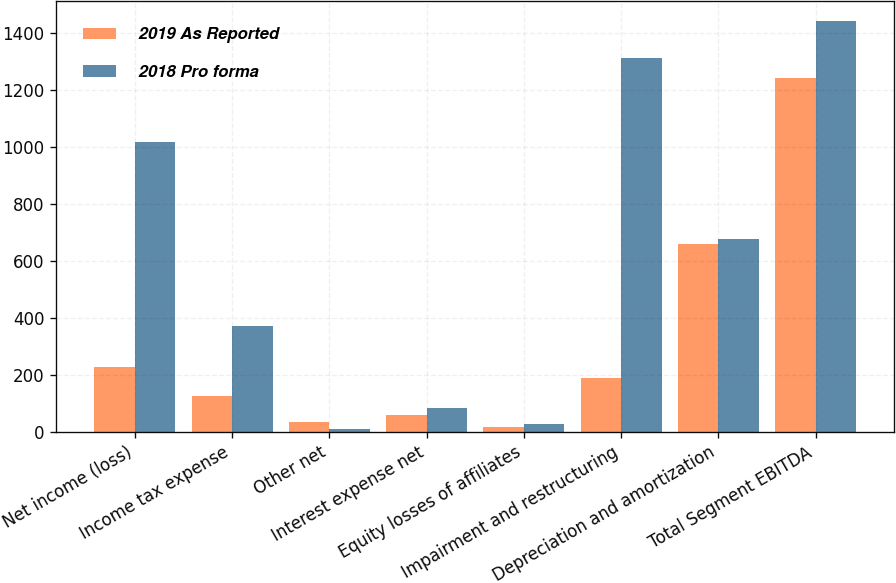Convert chart. <chart><loc_0><loc_0><loc_500><loc_500><stacked_bar_chart><ecel><fcel>Net income (loss)<fcel>Income tax expense<fcel>Other net<fcel>Interest expense net<fcel>Equity losses of affiliates<fcel>Impairment and restructuring<fcel>Depreciation and amortization<fcel>Total Segment EBITDA<nl><fcel>2019 As Reported<fcel>228<fcel>126<fcel>33<fcel>59<fcel>17<fcel>188<fcel>659<fcel>1244<nl><fcel>2018 Pro forma<fcel>1018<fcel>373<fcel>11<fcel>83<fcel>27<fcel>1313<fcel>676<fcel>1443<nl></chart> 